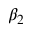Convert formula to latex. <formula><loc_0><loc_0><loc_500><loc_500>\beta _ { 2 }</formula> 